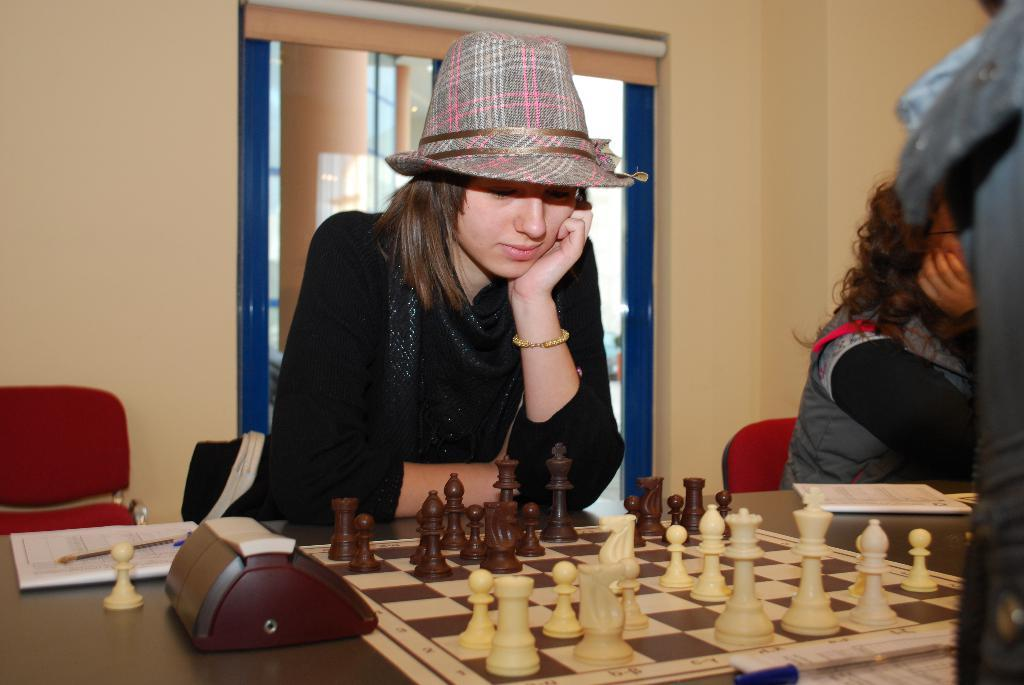Who is present in the image? There is a lady in the image. What is the lady wearing? The lady is wearing a black dress. What is the lady doing in the image? The lady is sitting on a chair. What objects can be seen on the table in the image? There is a chess board and a paper on the table. What type of guitar is the lady playing in the image? There is no guitar present in the image; the lady is sitting on a chair and there is a chess board and a paper on the table. 